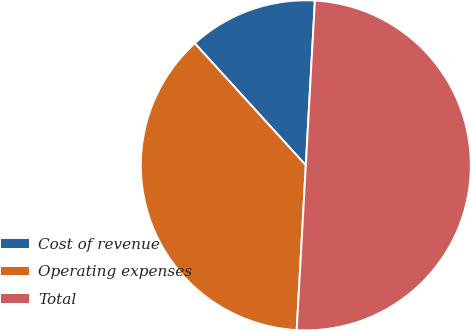Convert chart. <chart><loc_0><loc_0><loc_500><loc_500><pie_chart><fcel>Cost of revenue<fcel>Operating expenses<fcel>Total<nl><fcel>12.63%<fcel>37.37%<fcel>50.0%<nl></chart> 